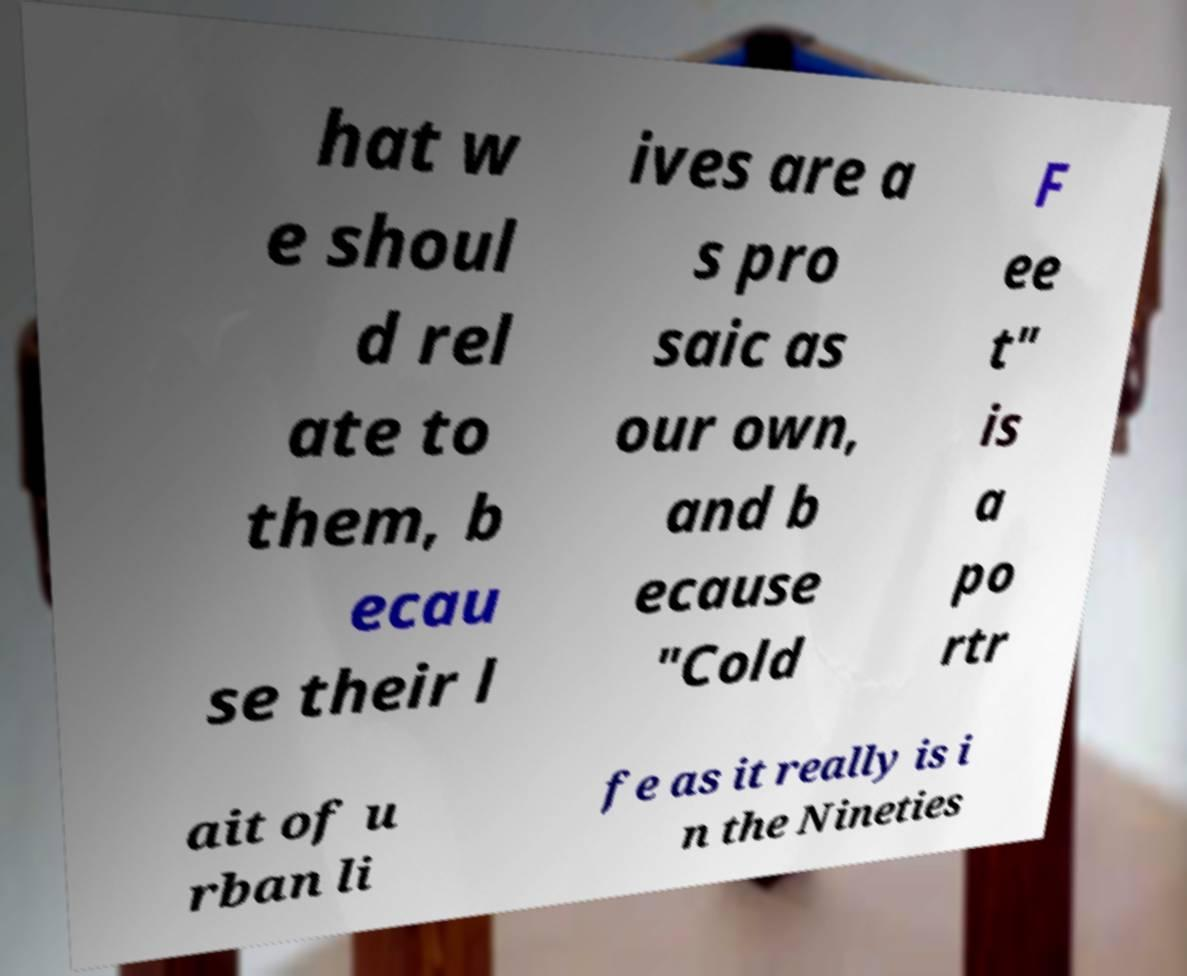Could you extract and type out the text from this image? hat w e shoul d rel ate to them, b ecau se their l ives are a s pro saic as our own, and b ecause "Cold F ee t" is a po rtr ait of u rban li fe as it really is i n the Nineties 